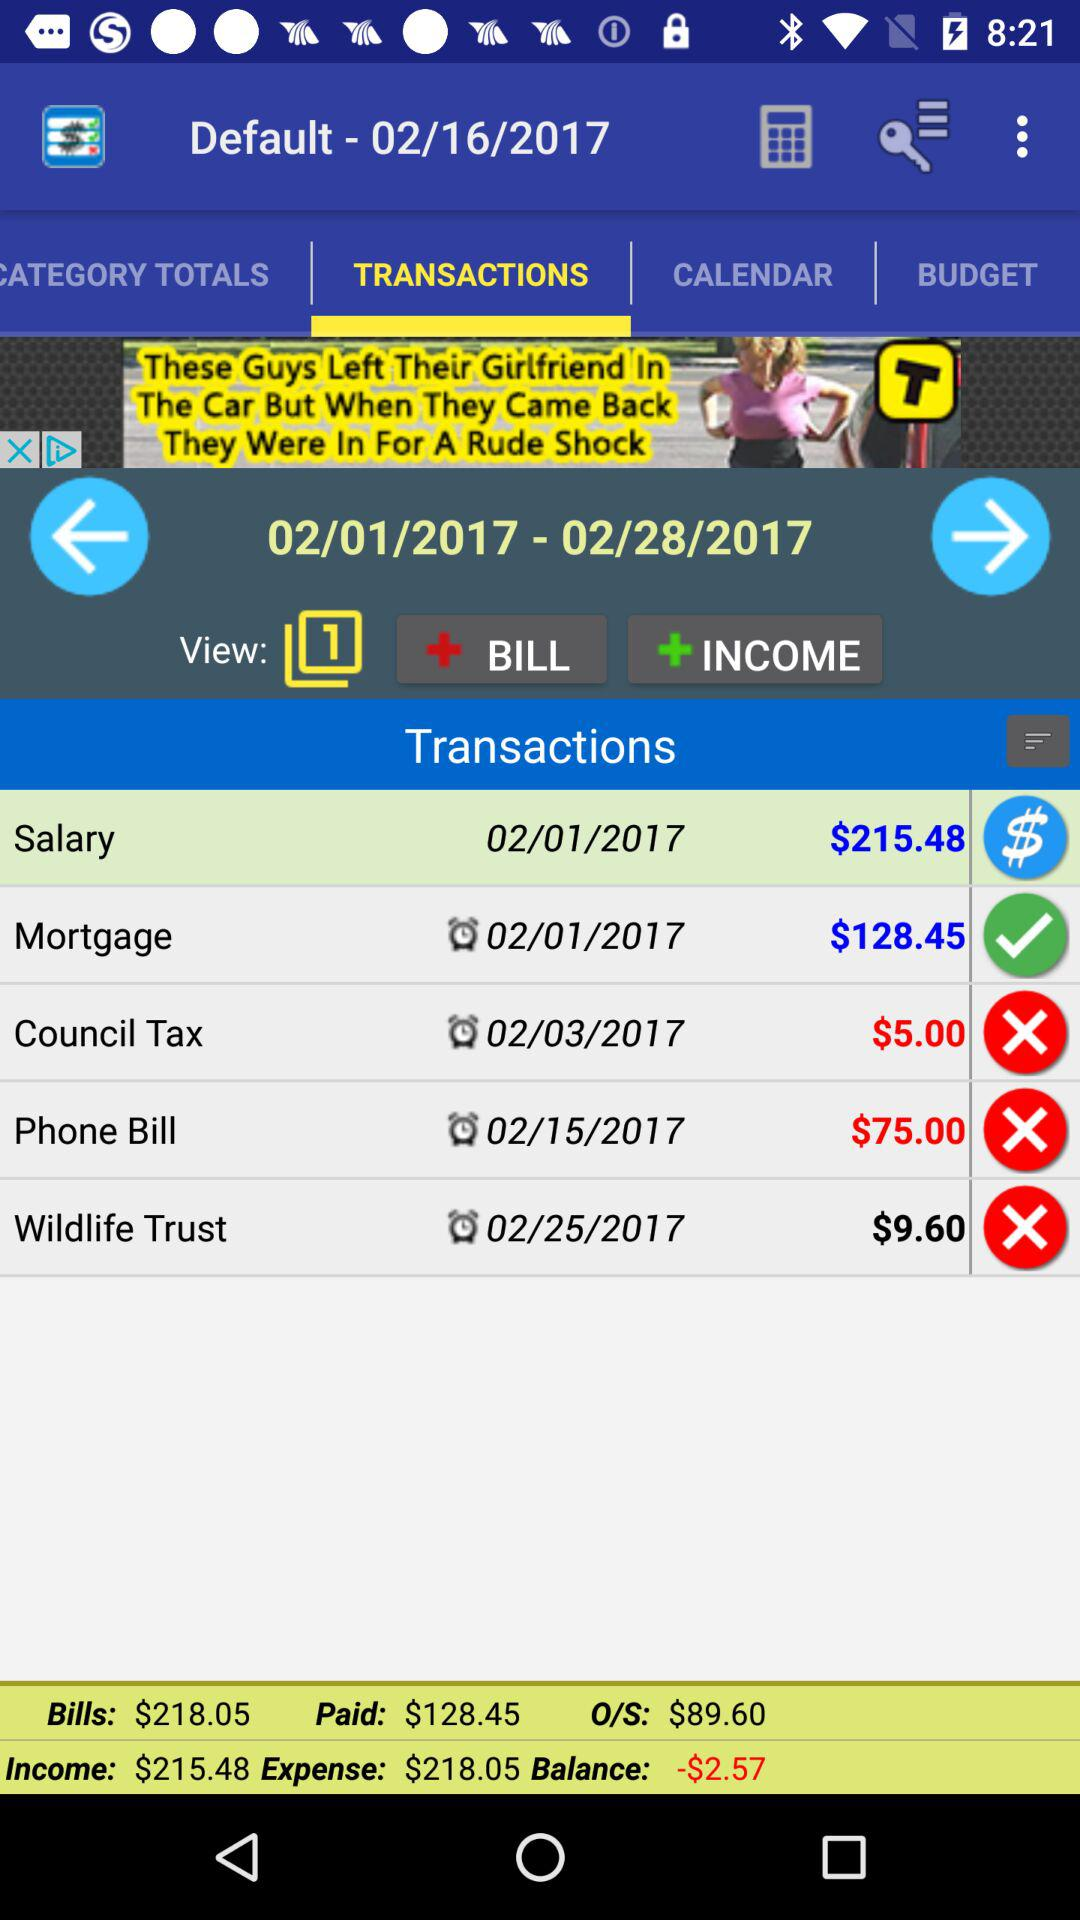How much do I owe in bills?
Answer the question using a single word or phrase. $89.60 